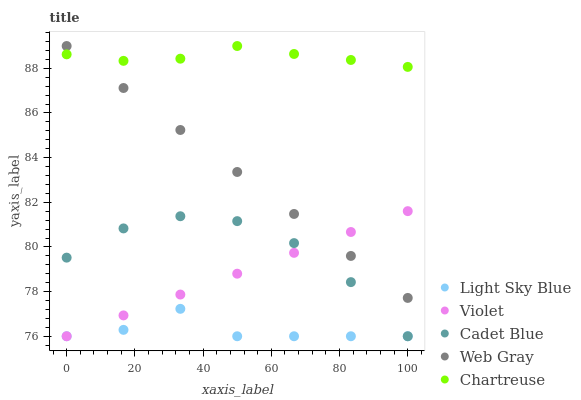Does Light Sky Blue have the minimum area under the curve?
Answer yes or no. Yes. Does Chartreuse have the maximum area under the curve?
Answer yes or no. Yes. Does Chartreuse have the minimum area under the curve?
Answer yes or no. No. Does Light Sky Blue have the maximum area under the curve?
Answer yes or no. No. Is Violet the smoothest?
Answer yes or no. Yes. Is Light Sky Blue the roughest?
Answer yes or no. Yes. Is Chartreuse the smoothest?
Answer yes or no. No. Is Chartreuse the roughest?
Answer yes or no. No. Does Cadet Blue have the lowest value?
Answer yes or no. Yes. Does Chartreuse have the lowest value?
Answer yes or no. No. Does Web Gray have the highest value?
Answer yes or no. Yes. Does Light Sky Blue have the highest value?
Answer yes or no. No. Is Light Sky Blue less than Chartreuse?
Answer yes or no. Yes. Is Chartreuse greater than Violet?
Answer yes or no. Yes. Does Light Sky Blue intersect Cadet Blue?
Answer yes or no. Yes. Is Light Sky Blue less than Cadet Blue?
Answer yes or no. No. Is Light Sky Blue greater than Cadet Blue?
Answer yes or no. No. Does Light Sky Blue intersect Chartreuse?
Answer yes or no. No. 